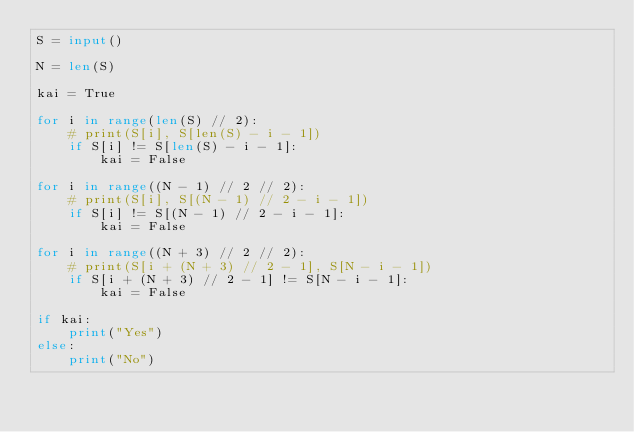Convert code to text. <code><loc_0><loc_0><loc_500><loc_500><_Python_>S = input()

N = len(S)

kai = True

for i in range(len(S) // 2):
    # print(S[i], S[len(S) - i - 1])
    if S[i] != S[len(S) - i - 1]:
        kai = False

for i in range((N - 1) // 2 // 2):
    # print(S[i], S[(N - 1) // 2 - i - 1])
    if S[i] != S[(N - 1) // 2 - i - 1]:
        kai = False

for i in range((N + 3) // 2 // 2):
    # print(S[i + (N + 3) // 2 - 1], S[N - i - 1])
    if S[i + (N + 3) // 2 - 1] != S[N - i - 1]:
        kai = False

if kai:
    print("Yes")
else:
    print("No")
</code> 